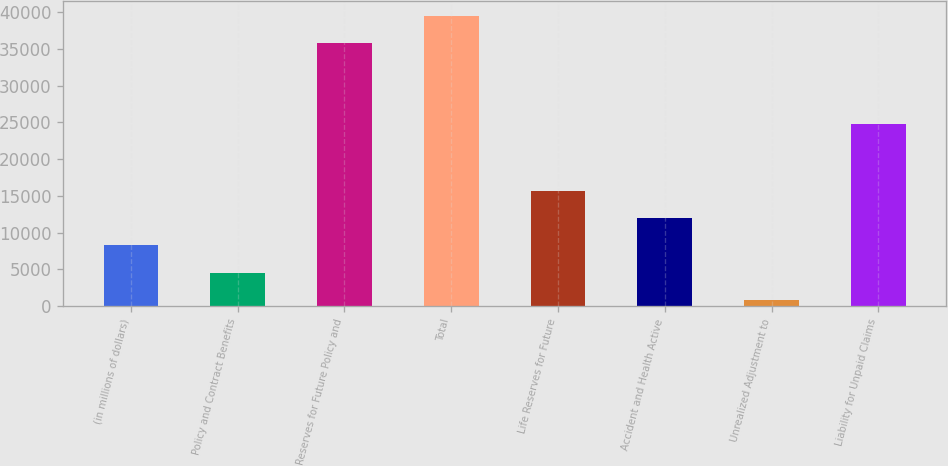Convert chart to OTSL. <chart><loc_0><loc_0><loc_500><loc_500><bar_chart><fcel>(in millions of dollars)<fcel>Policy and Contract Benefits<fcel>Reserves for Future Policy and<fcel>Total<fcel>Life Reserves for Future<fcel>Accident and Health Active<fcel>Unrealized Adjustment to<fcel>Liability for Unpaid Claims<nl><fcel>8248.98<fcel>4554.14<fcel>35828<fcel>39522.8<fcel>15638.7<fcel>11943.8<fcel>859.3<fcel>24790<nl></chart> 